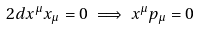<formula> <loc_0><loc_0><loc_500><loc_500>2 d x ^ { \mu } x _ { \mu } = 0 \implies x ^ { \mu } p _ { \mu } = 0</formula> 